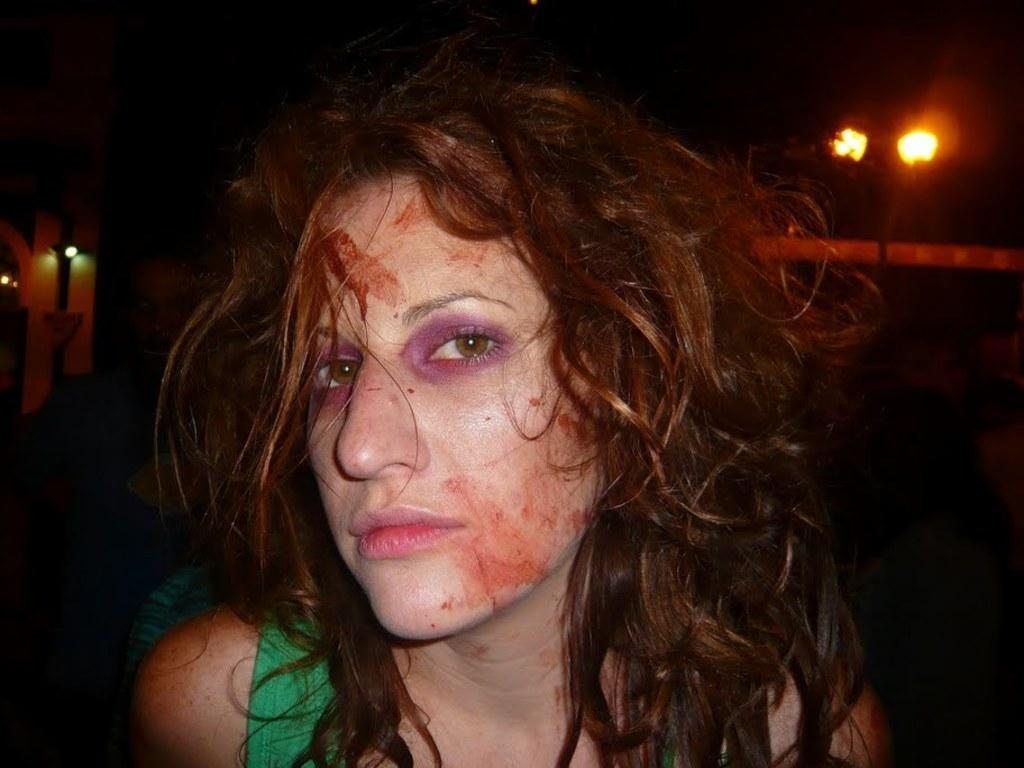Who is the main subject in the image? There is a woman in the image. What is the woman doing in the image? The woman is looking at a picture. Can you describe any unique features about the woman? There are red color marks on her face. What can be seen in the background of the image? There are lights in the background of the image, and the background is dark. What month is the pig celebrating in the image? There is no pig present in the image, and therefore no celebration or month can be observed. What is the woman's mindset while looking at the picture in the image? The image does not provide information about the woman's mindset or emotions while looking at the picture. 